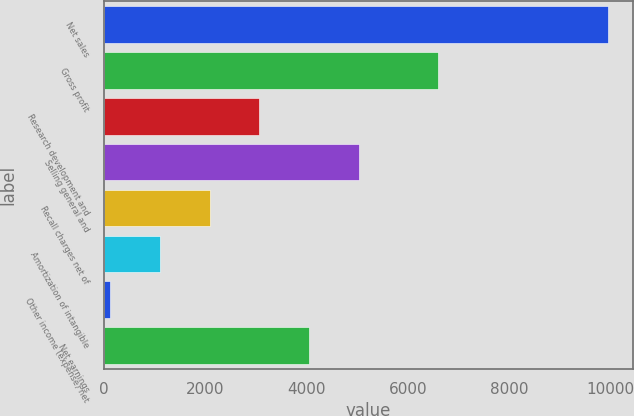Convert chart to OTSL. <chart><loc_0><loc_0><loc_500><loc_500><bar_chart><fcel>Net sales<fcel>Gross profit<fcel>Research development and<fcel>Selling general and<fcel>Recall charges net of<fcel>Amortization of intangible<fcel>Other income (expense) net<fcel>Net earnings<nl><fcel>9946<fcel>6602<fcel>3072<fcel>5036<fcel>2090<fcel>1108<fcel>126<fcel>4054<nl></chart> 